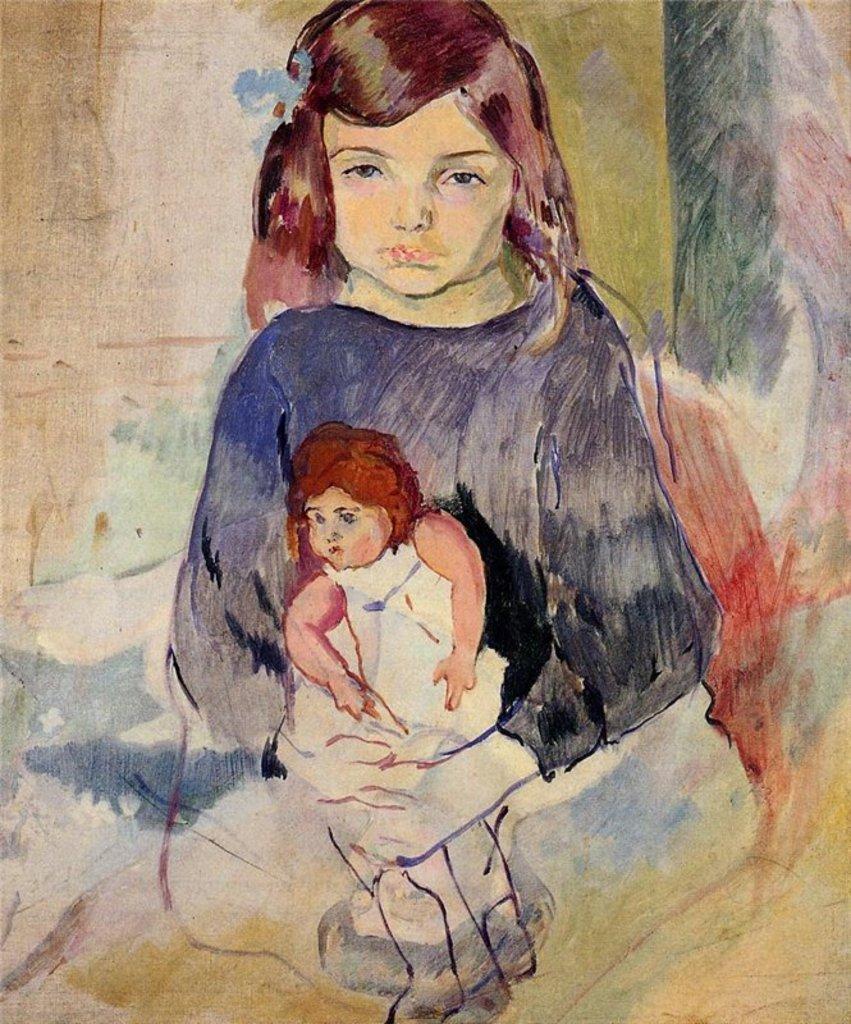Describe this image in one or two sentences. In this image we can see the painting of a girl, and a doll. 